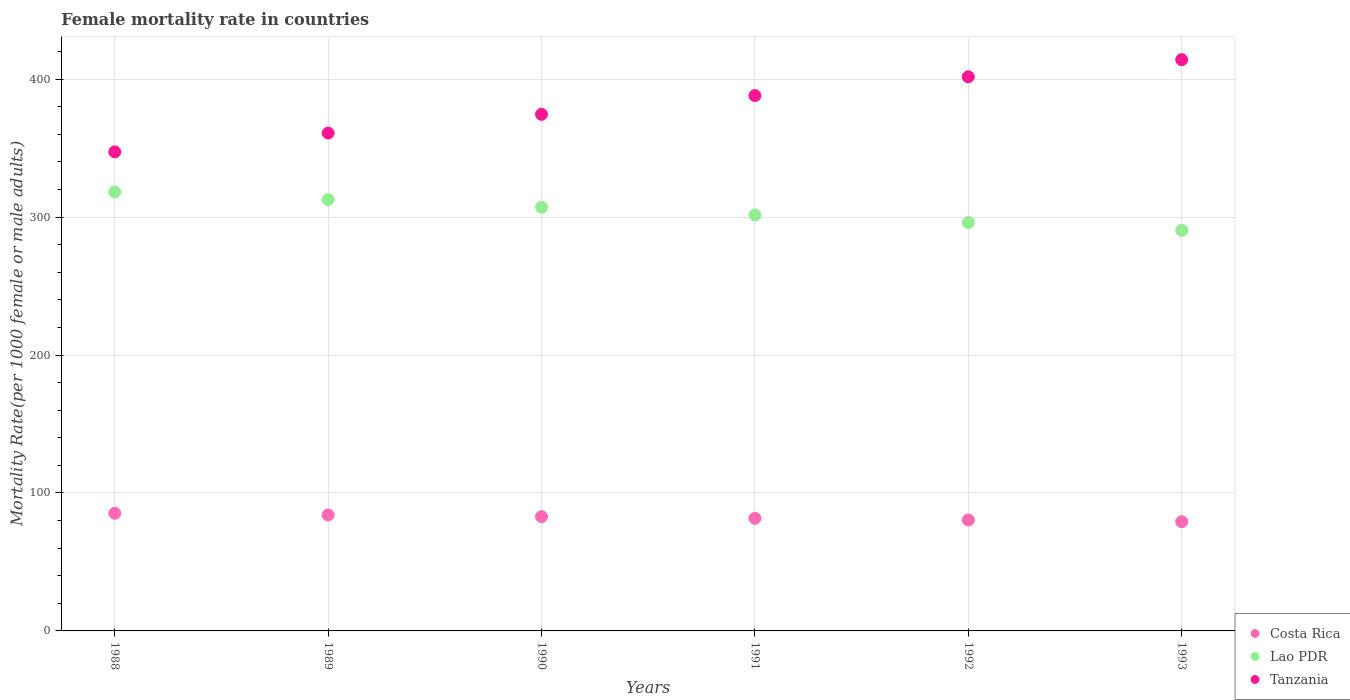What is the female mortality rate in Lao PDR in 1989?
Make the answer very short. 312.73. Across all years, what is the maximum female mortality rate in Lao PDR?
Provide a short and direct response. 318.29. Across all years, what is the minimum female mortality rate in Costa Rica?
Provide a succinct answer. 79.2. In which year was the female mortality rate in Lao PDR minimum?
Offer a terse response. 1993. What is the total female mortality rate in Lao PDR in the graph?
Provide a short and direct response. 1826.27. What is the difference between the female mortality rate in Costa Rica in 1989 and that in 1990?
Your answer should be very brief. 1.21. What is the difference between the female mortality rate in Tanzania in 1988 and the female mortality rate in Lao PDR in 1990?
Give a very brief answer. 40.15. What is the average female mortality rate in Lao PDR per year?
Your answer should be compact. 304.38. In the year 1993, what is the difference between the female mortality rate in Tanzania and female mortality rate in Costa Rica?
Your answer should be compact. 334.95. What is the ratio of the female mortality rate in Tanzania in 1990 to that in 1993?
Your response must be concise. 0.9. Is the female mortality rate in Costa Rica in 1989 less than that in 1991?
Offer a terse response. No. What is the difference between the highest and the second highest female mortality rate in Lao PDR?
Offer a terse response. 5.56. What is the difference between the highest and the lowest female mortality rate in Tanzania?
Make the answer very short. 66.83. Is the sum of the female mortality rate in Tanzania in 1989 and 1991 greater than the maximum female mortality rate in Costa Rica across all years?
Offer a terse response. Yes. How many years are there in the graph?
Your answer should be compact. 6. Are the values on the major ticks of Y-axis written in scientific E-notation?
Ensure brevity in your answer.  No. Does the graph contain any zero values?
Ensure brevity in your answer.  No. Where does the legend appear in the graph?
Offer a terse response. Bottom right. How are the legend labels stacked?
Your answer should be compact. Vertical. What is the title of the graph?
Ensure brevity in your answer.  Female mortality rate in countries. Does "Lesotho" appear as one of the legend labels in the graph?
Provide a short and direct response. No. What is the label or title of the X-axis?
Give a very brief answer. Years. What is the label or title of the Y-axis?
Keep it short and to the point. Mortality Rate(per 1000 female or male adults). What is the Mortality Rate(per 1000 female or male adults) in Costa Rica in 1988?
Offer a terse response. 85.29. What is the Mortality Rate(per 1000 female or male adults) of Lao PDR in 1988?
Give a very brief answer. 318.29. What is the Mortality Rate(per 1000 female or male adults) in Tanzania in 1988?
Make the answer very short. 347.31. What is the Mortality Rate(per 1000 female or male adults) in Costa Rica in 1989?
Provide a succinct answer. 84.08. What is the Mortality Rate(per 1000 female or male adults) in Lao PDR in 1989?
Provide a succinct answer. 312.73. What is the Mortality Rate(per 1000 female or male adults) of Tanzania in 1989?
Offer a very short reply. 360.92. What is the Mortality Rate(per 1000 female or male adults) in Costa Rica in 1990?
Give a very brief answer. 82.87. What is the Mortality Rate(per 1000 female or male adults) of Lao PDR in 1990?
Offer a terse response. 307.17. What is the Mortality Rate(per 1000 female or male adults) of Tanzania in 1990?
Keep it short and to the point. 374.53. What is the Mortality Rate(per 1000 female or male adults) of Costa Rica in 1991?
Offer a terse response. 81.65. What is the Mortality Rate(per 1000 female or male adults) in Lao PDR in 1991?
Make the answer very short. 301.6. What is the Mortality Rate(per 1000 female or male adults) of Tanzania in 1991?
Provide a short and direct response. 388.13. What is the Mortality Rate(per 1000 female or male adults) in Costa Rica in 1992?
Provide a succinct answer. 80.44. What is the Mortality Rate(per 1000 female or male adults) of Lao PDR in 1992?
Make the answer very short. 296.04. What is the Mortality Rate(per 1000 female or male adults) in Tanzania in 1992?
Your answer should be very brief. 401.74. What is the Mortality Rate(per 1000 female or male adults) in Costa Rica in 1993?
Provide a short and direct response. 79.2. What is the Mortality Rate(per 1000 female or male adults) in Lao PDR in 1993?
Your response must be concise. 290.44. What is the Mortality Rate(per 1000 female or male adults) in Tanzania in 1993?
Offer a very short reply. 414.15. Across all years, what is the maximum Mortality Rate(per 1000 female or male adults) of Costa Rica?
Offer a very short reply. 85.29. Across all years, what is the maximum Mortality Rate(per 1000 female or male adults) in Lao PDR?
Your answer should be compact. 318.29. Across all years, what is the maximum Mortality Rate(per 1000 female or male adults) of Tanzania?
Ensure brevity in your answer.  414.15. Across all years, what is the minimum Mortality Rate(per 1000 female or male adults) of Costa Rica?
Make the answer very short. 79.2. Across all years, what is the minimum Mortality Rate(per 1000 female or male adults) in Lao PDR?
Provide a short and direct response. 290.44. Across all years, what is the minimum Mortality Rate(per 1000 female or male adults) of Tanzania?
Provide a short and direct response. 347.31. What is the total Mortality Rate(per 1000 female or male adults) of Costa Rica in the graph?
Your response must be concise. 493.53. What is the total Mortality Rate(per 1000 female or male adults) of Lao PDR in the graph?
Keep it short and to the point. 1826.27. What is the total Mortality Rate(per 1000 female or male adults) in Tanzania in the graph?
Offer a very short reply. 2286.78. What is the difference between the Mortality Rate(per 1000 female or male adults) of Costa Rica in 1988 and that in 1989?
Keep it short and to the point. 1.21. What is the difference between the Mortality Rate(per 1000 female or male adults) in Lao PDR in 1988 and that in 1989?
Offer a terse response. 5.56. What is the difference between the Mortality Rate(per 1000 female or male adults) in Tanzania in 1988 and that in 1989?
Keep it short and to the point. -13.61. What is the difference between the Mortality Rate(per 1000 female or male adults) in Costa Rica in 1988 and that in 1990?
Your answer should be very brief. 2.42. What is the difference between the Mortality Rate(per 1000 female or male adults) in Lao PDR in 1988 and that in 1990?
Your answer should be compact. 11.13. What is the difference between the Mortality Rate(per 1000 female or male adults) of Tanzania in 1988 and that in 1990?
Offer a terse response. -27.21. What is the difference between the Mortality Rate(per 1000 female or male adults) of Costa Rica in 1988 and that in 1991?
Provide a succinct answer. 3.64. What is the difference between the Mortality Rate(per 1000 female or male adults) in Lao PDR in 1988 and that in 1991?
Offer a very short reply. 16.69. What is the difference between the Mortality Rate(per 1000 female or male adults) in Tanzania in 1988 and that in 1991?
Ensure brevity in your answer.  -40.82. What is the difference between the Mortality Rate(per 1000 female or male adults) of Costa Rica in 1988 and that in 1992?
Offer a very short reply. 4.85. What is the difference between the Mortality Rate(per 1000 female or male adults) of Lao PDR in 1988 and that in 1992?
Your answer should be compact. 22.25. What is the difference between the Mortality Rate(per 1000 female or male adults) of Tanzania in 1988 and that in 1992?
Give a very brief answer. -54.43. What is the difference between the Mortality Rate(per 1000 female or male adults) in Costa Rica in 1988 and that in 1993?
Keep it short and to the point. 6.09. What is the difference between the Mortality Rate(per 1000 female or male adults) of Lao PDR in 1988 and that in 1993?
Keep it short and to the point. 27.85. What is the difference between the Mortality Rate(per 1000 female or male adults) of Tanzania in 1988 and that in 1993?
Give a very brief answer. -66.83. What is the difference between the Mortality Rate(per 1000 female or male adults) of Costa Rica in 1989 and that in 1990?
Your answer should be compact. 1.21. What is the difference between the Mortality Rate(per 1000 female or male adults) in Lao PDR in 1989 and that in 1990?
Your response must be concise. 5.56. What is the difference between the Mortality Rate(per 1000 female or male adults) of Tanzania in 1989 and that in 1990?
Your answer should be compact. -13.61. What is the difference between the Mortality Rate(per 1000 female or male adults) of Costa Rica in 1989 and that in 1991?
Ensure brevity in your answer.  2.42. What is the difference between the Mortality Rate(per 1000 female or male adults) in Lao PDR in 1989 and that in 1991?
Make the answer very short. 11.13. What is the difference between the Mortality Rate(per 1000 female or male adults) in Tanzania in 1989 and that in 1991?
Your answer should be very brief. -27.21. What is the difference between the Mortality Rate(per 1000 female or male adults) of Costa Rica in 1989 and that in 1992?
Your answer should be very brief. 3.64. What is the difference between the Mortality Rate(per 1000 female or male adults) of Lao PDR in 1989 and that in 1992?
Ensure brevity in your answer.  16.69. What is the difference between the Mortality Rate(per 1000 female or male adults) of Tanzania in 1989 and that in 1992?
Provide a short and direct response. -40.82. What is the difference between the Mortality Rate(per 1000 female or male adults) of Costa Rica in 1989 and that in 1993?
Offer a very short reply. 4.88. What is the difference between the Mortality Rate(per 1000 female or male adults) in Lao PDR in 1989 and that in 1993?
Provide a short and direct response. 22.28. What is the difference between the Mortality Rate(per 1000 female or male adults) in Tanzania in 1989 and that in 1993?
Give a very brief answer. -53.23. What is the difference between the Mortality Rate(per 1000 female or male adults) in Costa Rica in 1990 and that in 1991?
Ensure brevity in your answer.  1.21. What is the difference between the Mortality Rate(per 1000 female or male adults) in Lao PDR in 1990 and that in 1991?
Your response must be concise. 5.56. What is the difference between the Mortality Rate(per 1000 female or male adults) in Tanzania in 1990 and that in 1991?
Provide a succinct answer. -13.61. What is the difference between the Mortality Rate(per 1000 female or male adults) in Costa Rica in 1990 and that in 1992?
Keep it short and to the point. 2.42. What is the difference between the Mortality Rate(per 1000 female or male adults) in Lao PDR in 1990 and that in 1992?
Provide a short and direct response. 11.13. What is the difference between the Mortality Rate(per 1000 female or male adults) of Tanzania in 1990 and that in 1992?
Give a very brief answer. -27.21. What is the difference between the Mortality Rate(per 1000 female or male adults) in Costa Rica in 1990 and that in 1993?
Ensure brevity in your answer.  3.67. What is the difference between the Mortality Rate(per 1000 female or male adults) of Lao PDR in 1990 and that in 1993?
Your response must be concise. 16.72. What is the difference between the Mortality Rate(per 1000 female or male adults) in Tanzania in 1990 and that in 1993?
Offer a very short reply. -39.62. What is the difference between the Mortality Rate(per 1000 female or male adults) in Costa Rica in 1991 and that in 1992?
Give a very brief answer. 1.21. What is the difference between the Mortality Rate(per 1000 female or male adults) of Lao PDR in 1991 and that in 1992?
Your answer should be compact. 5.56. What is the difference between the Mortality Rate(per 1000 female or male adults) of Tanzania in 1991 and that in 1992?
Keep it short and to the point. -13.61. What is the difference between the Mortality Rate(per 1000 female or male adults) of Costa Rica in 1991 and that in 1993?
Make the answer very short. 2.45. What is the difference between the Mortality Rate(per 1000 female or male adults) of Lao PDR in 1991 and that in 1993?
Provide a short and direct response. 11.16. What is the difference between the Mortality Rate(per 1000 female or male adults) of Tanzania in 1991 and that in 1993?
Ensure brevity in your answer.  -26.01. What is the difference between the Mortality Rate(per 1000 female or male adults) in Costa Rica in 1992 and that in 1993?
Make the answer very short. 1.24. What is the difference between the Mortality Rate(per 1000 female or male adults) in Lao PDR in 1992 and that in 1993?
Your answer should be very brief. 5.59. What is the difference between the Mortality Rate(per 1000 female or male adults) in Tanzania in 1992 and that in 1993?
Your response must be concise. -12.41. What is the difference between the Mortality Rate(per 1000 female or male adults) of Costa Rica in 1988 and the Mortality Rate(per 1000 female or male adults) of Lao PDR in 1989?
Your response must be concise. -227.44. What is the difference between the Mortality Rate(per 1000 female or male adults) of Costa Rica in 1988 and the Mortality Rate(per 1000 female or male adults) of Tanzania in 1989?
Give a very brief answer. -275.63. What is the difference between the Mortality Rate(per 1000 female or male adults) in Lao PDR in 1988 and the Mortality Rate(per 1000 female or male adults) in Tanzania in 1989?
Your response must be concise. -42.63. What is the difference between the Mortality Rate(per 1000 female or male adults) of Costa Rica in 1988 and the Mortality Rate(per 1000 female or male adults) of Lao PDR in 1990?
Ensure brevity in your answer.  -221.87. What is the difference between the Mortality Rate(per 1000 female or male adults) of Costa Rica in 1988 and the Mortality Rate(per 1000 female or male adults) of Tanzania in 1990?
Your response must be concise. -289.24. What is the difference between the Mortality Rate(per 1000 female or male adults) of Lao PDR in 1988 and the Mortality Rate(per 1000 female or male adults) of Tanzania in 1990?
Provide a succinct answer. -56.24. What is the difference between the Mortality Rate(per 1000 female or male adults) in Costa Rica in 1988 and the Mortality Rate(per 1000 female or male adults) in Lao PDR in 1991?
Offer a very short reply. -216.31. What is the difference between the Mortality Rate(per 1000 female or male adults) of Costa Rica in 1988 and the Mortality Rate(per 1000 female or male adults) of Tanzania in 1991?
Provide a succinct answer. -302.84. What is the difference between the Mortality Rate(per 1000 female or male adults) in Lao PDR in 1988 and the Mortality Rate(per 1000 female or male adults) in Tanzania in 1991?
Provide a succinct answer. -69.84. What is the difference between the Mortality Rate(per 1000 female or male adults) in Costa Rica in 1988 and the Mortality Rate(per 1000 female or male adults) in Lao PDR in 1992?
Keep it short and to the point. -210.75. What is the difference between the Mortality Rate(per 1000 female or male adults) of Costa Rica in 1988 and the Mortality Rate(per 1000 female or male adults) of Tanzania in 1992?
Keep it short and to the point. -316.45. What is the difference between the Mortality Rate(per 1000 female or male adults) in Lao PDR in 1988 and the Mortality Rate(per 1000 female or male adults) in Tanzania in 1992?
Your answer should be compact. -83.45. What is the difference between the Mortality Rate(per 1000 female or male adults) in Costa Rica in 1988 and the Mortality Rate(per 1000 female or male adults) in Lao PDR in 1993?
Your answer should be very brief. -205.15. What is the difference between the Mortality Rate(per 1000 female or male adults) in Costa Rica in 1988 and the Mortality Rate(per 1000 female or male adults) in Tanzania in 1993?
Keep it short and to the point. -328.86. What is the difference between the Mortality Rate(per 1000 female or male adults) in Lao PDR in 1988 and the Mortality Rate(per 1000 female or male adults) in Tanzania in 1993?
Offer a terse response. -95.86. What is the difference between the Mortality Rate(per 1000 female or male adults) of Costa Rica in 1989 and the Mortality Rate(per 1000 female or male adults) of Lao PDR in 1990?
Ensure brevity in your answer.  -223.09. What is the difference between the Mortality Rate(per 1000 female or male adults) in Costa Rica in 1989 and the Mortality Rate(per 1000 female or male adults) in Tanzania in 1990?
Your response must be concise. -290.45. What is the difference between the Mortality Rate(per 1000 female or male adults) of Lao PDR in 1989 and the Mortality Rate(per 1000 female or male adults) of Tanzania in 1990?
Offer a very short reply. -61.8. What is the difference between the Mortality Rate(per 1000 female or male adults) of Costa Rica in 1989 and the Mortality Rate(per 1000 female or male adults) of Lao PDR in 1991?
Your answer should be compact. -217.52. What is the difference between the Mortality Rate(per 1000 female or male adults) in Costa Rica in 1989 and the Mortality Rate(per 1000 female or male adults) in Tanzania in 1991?
Offer a very short reply. -304.06. What is the difference between the Mortality Rate(per 1000 female or male adults) in Lao PDR in 1989 and the Mortality Rate(per 1000 female or male adults) in Tanzania in 1991?
Your answer should be compact. -75.41. What is the difference between the Mortality Rate(per 1000 female or male adults) of Costa Rica in 1989 and the Mortality Rate(per 1000 female or male adults) of Lao PDR in 1992?
Provide a succinct answer. -211.96. What is the difference between the Mortality Rate(per 1000 female or male adults) in Costa Rica in 1989 and the Mortality Rate(per 1000 female or male adults) in Tanzania in 1992?
Give a very brief answer. -317.66. What is the difference between the Mortality Rate(per 1000 female or male adults) of Lao PDR in 1989 and the Mortality Rate(per 1000 female or male adults) of Tanzania in 1992?
Provide a short and direct response. -89.01. What is the difference between the Mortality Rate(per 1000 female or male adults) of Costa Rica in 1989 and the Mortality Rate(per 1000 female or male adults) of Lao PDR in 1993?
Your answer should be very brief. -206.37. What is the difference between the Mortality Rate(per 1000 female or male adults) of Costa Rica in 1989 and the Mortality Rate(per 1000 female or male adults) of Tanzania in 1993?
Provide a short and direct response. -330.07. What is the difference between the Mortality Rate(per 1000 female or male adults) of Lao PDR in 1989 and the Mortality Rate(per 1000 female or male adults) of Tanzania in 1993?
Your response must be concise. -101.42. What is the difference between the Mortality Rate(per 1000 female or male adults) in Costa Rica in 1990 and the Mortality Rate(per 1000 female or male adults) in Lao PDR in 1991?
Offer a very short reply. -218.74. What is the difference between the Mortality Rate(per 1000 female or male adults) in Costa Rica in 1990 and the Mortality Rate(per 1000 female or male adults) in Tanzania in 1991?
Provide a succinct answer. -305.27. What is the difference between the Mortality Rate(per 1000 female or male adults) of Lao PDR in 1990 and the Mortality Rate(per 1000 female or male adults) of Tanzania in 1991?
Offer a terse response. -80.97. What is the difference between the Mortality Rate(per 1000 female or male adults) of Costa Rica in 1990 and the Mortality Rate(per 1000 female or male adults) of Lao PDR in 1992?
Your answer should be compact. -213.17. What is the difference between the Mortality Rate(per 1000 female or male adults) of Costa Rica in 1990 and the Mortality Rate(per 1000 female or male adults) of Tanzania in 1992?
Offer a very short reply. -318.87. What is the difference between the Mortality Rate(per 1000 female or male adults) in Lao PDR in 1990 and the Mortality Rate(per 1000 female or male adults) in Tanzania in 1992?
Give a very brief answer. -94.58. What is the difference between the Mortality Rate(per 1000 female or male adults) in Costa Rica in 1990 and the Mortality Rate(per 1000 female or male adults) in Lao PDR in 1993?
Offer a very short reply. -207.58. What is the difference between the Mortality Rate(per 1000 female or male adults) in Costa Rica in 1990 and the Mortality Rate(per 1000 female or male adults) in Tanzania in 1993?
Your answer should be compact. -331.28. What is the difference between the Mortality Rate(per 1000 female or male adults) of Lao PDR in 1990 and the Mortality Rate(per 1000 female or male adults) of Tanzania in 1993?
Make the answer very short. -106.98. What is the difference between the Mortality Rate(per 1000 female or male adults) of Costa Rica in 1991 and the Mortality Rate(per 1000 female or male adults) of Lao PDR in 1992?
Provide a succinct answer. -214.39. What is the difference between the Mortality Rate(per 1000 female or male adults) of Costa Rica in 1991 and the Mortality Rate(per 1000 female or male adults) of Tanzania in 1992?
Your answer should be very brief. -320.09. What is the difference between the Mortality Rate(per 1000 female or male adults) in Lao PDR in 1991 and the Mortality Rate(per 1000 female or male adults) in Tanzania in 1992?
Your answer should be very brief. -100.14. What is the difference between the Mortality Rate(per 1000 female or male adults) in Costa Rica in 1991 and the Mortality Rate(per 1000 female or male adults) in Lao PDR in 1993?
Ensure brevity in your answer.  -208.79. What is the difference between the Mortality Rate(per 1000 female or male adults) in Costa Rica in 1991 and the Mortality Rate(per 1000 female or male adults) in Tanzania in 1993?
Offer a very short reply. -332.49. What is the difference between the Mortality Rate(per 1000 female or male adults) in Lao PDR in 1991 and the Mortality Rate(per 1000 female or male adults) in Tanzania in 1993?
Keep it short and to the point. -112.55. What is the difference between the Mortality Rate(per 1000 female or male adults) of Costa Rica in 1992 and the Mortality Rate(per 1000 female or male adults) of Lao PDR in 1993?
Provide a succinct answer. -210. What is the difference between the Mortality Rate(per 1000 female or male adults) in Costa Rica in 1992 and the Mortality Rate(per 1000 female or male adults) in Tanzania in 1993?
Keep it short and to the point. -333.71. What is the difference between the Mortality Rate(per 1000 female or male adults) in Lao PDR in 1992 and the Mortality Rate(per 1000 female or male adults) in Tanzania in 1993?
Your answer should be very brief. -118.11. What is the average Mortality Rate(per 1000 female or male adults) of Costa Rica per year?
Your answer should be compact. 82.25. What is the average Mortality Rate(per 1000 female or male adults) of Lao PDR per year?
Provide a short and direct response. 304.38. What is the average Mortality Rate(per 1000 female or male adults) of Tanzania per year?
Provide a short and direct response. 381.13. In the year 1988, what is the difference between the Mortality Rate(per 1000 female or male adults) of Costa Rica and Mortality Rate(per 1000 female or male adults) of Lao PDR?
Provide a short and direct response. -233. In the year 1988, what is the difference between the Mortality Rate(per 1000 female or male adults) of Costa Rica and Mortality Rate(per 1000 female or male adults) of Tanzania?
Ensure brevity in your answer.  -262.02. In the year 1988, what is the difference between the Mortality Rate(per 1000 female or male adults) in Lao PDR and Mortality Rate(per 1000 female or male adults) in Tanzania?
Give a very brief answer. -29.02. In the year 1989, what is the difference between the Mortality Rate(per 1000 female or male adults) of Costa Rica and Mortality Rate(per 1000 female or male adults) of Lao PDR?
Ensure brevity in your answer.  -228.65. In the year 1989, what is the difference between the Mortality Rate(per 1000 female or male adults) in Costa Rica and Mortality Rate(per 1000 female or male adults) in Tanzania?
Your answer should be very brief. -276.84. In the year 1989, what is the difference between the Mortality Rate(per 1000 female or male adults) in Lao PDR and Mortality Rate(per 1000 female or male adults) in Tanzania?
Your response must be concise. -48.19. In the year 1990, what is the difference between the Mortality Rate(per 1000 female or male adults) in Costa Rica and Mortality Rate(per 1000 female or male adults) in Lao PDR?
Keep it short and to the point. -224.3. In the year 1990, what is the difference between the Mortality Rate(per 1000 female or male adults) of Costa Rica and Mortality Rate(per 1000 female or male adults) of Tanzania?
Give a very brief answer. -291.66. In the year 1990, what is the difference between the Mortality Rate(per 1000 female or male adults) in Lao PDR and Mortality Rate(per 1000 female or male adults) in Tanzania?
Make the answer very short. -67.36. In the year 1991, what is the difference between the Mortality Rate(per 1000 female or male adults) of Costa Rica and Mortality Rate(per 1000 female or male adults) of Lao PDR?
Offer a very short reply. -219.95. In the year 1991, what is the difference between the Mortality Rate(per 1000 female or male adults) in Costa Rica and Mortality Rate(per 1000 female or male adults) in Tanzania?
Your response must be concise. -306.48. In the year 1991, what is the difference between the Mortality Rate(per 1000 female or male adults) in Lao PDR and Mortality Rate(per 1000 female or male adults) in Tanzania?
Make the answer very short. -86.53. In the year 1992, what is the difference between the Mortality Rate(per 1000 female or male adults) of Costa Rica and Mortality Rate(per 1000 female or male adults) of Lao PDR?
Your response must be concise. -215.6. In the year 1992, what is the difference between the Mortality Rate(per 1000 female or male adults) of Costa Rica and Mortality Rate(per 1000 female or male adults) of Tanzania?
Ensure brevity in your answer.  -321.3. In the year 1992, what is the difference between the Mortality Rate(per 1000 female or male adults) in Lao PDR and Mortality Rate(per 1000 female or male adults) in Tanzania?
Provide a short and direct response. -105.7. In the year 1993, what is the difference between the Mortality Rate(per 1000 female or male adults) of Costa Rica and Mortality Rate(per 1000 female or male adults) of Lao PDR?
Provide a short and direct response. -211.24. In the year 1993, what is the difference between the Mortality Rate(per 1000 female or male adults) in Costa Rica and Mortality Rate(per 1000 female or male adults) in Tanzania?
Your response must be concise. -334.95. In the year 1993, what is the difference between the Mortality Rate(per 1000 female or male adults) of Lao PDR and Mortality Rate(per 1000 female or male adults) of Tanzania?
Make the answer very short. -123.7. What is the ratio of the Mortality Rate(per 1000 female or male adults) of Costa Rica in 1988 to that in 1989?
Make the answer very short. 1.01. What is the ratio of the Mortality Rate(per 1000 female or male adults) in Lao PDR in 1988 to that in 1989?
Offer a terse response. 1.02. What is the ratio of the Mortality Rate(per 1000 female or male adults) in Tanzania in 1988 to that in 1989?
Offer a terse response. 0.96. What is the ratio of the Mortality Rate(per 1000 female or male adults) in Costa Rica in 1988 to that in 1990?
Offer a terse response. 1.03. What is the ratio of the Mortality Rate(per 1000 female or male adults) of Lao PDR in 1988 to that in 1990?
Offer a terse response. 1.04. What is the ratio of the Mortality Rate(per 1000 female or male adults) of Tanzania in 1988 to that in 1990?
Provide a short and direct response. 0.93. What is the ratio of the Mortality Rate(per 1000 female or male adults) in Costa Rica in 1988 to that in 1991?
Your answer should be compact. 1.04. What is the ratio of the Mortality Rate(per 1000 female or male adults) of Lao PDR in 1988 to that in 1991?
Make the answer very short. 1.06. What is the ratio of the Mortality Rate(per 1000 female or male adults) in Tanzania in 1988 to that in 1991?
Your answer should be very brief. 0.89. What is the ratio of the Mortality Rate(per 1000 female or male adults) in Costa Rica in 1988 to that in 1992?
Make the answer very short. 1.06. What is the ratio of the Mortality Rate(per 1000 female or male adults) of Lao PDR in 1988 to that in 1992?
Offer a terse response. 1.08. What is the ratio of the Mortality Rate(per 1000 female or male adults) in Tanzania in 1988 to that in 1992?
Keep it short and to the point. 0.86. What is the ratio of the Mortality Rate(per 1000 female or male adults) in Costa Rica in 1988 to that in 1993?
Give a very brief answer. 1.08. What is the ratio of the Mortality Rate(per 1000 female or male adults) of Lao PDR in 1988 to that in 1993?
Make the answer very short. 1.1. What is the ratio of the Mortality Rate(per 1000 female or male adults) of Tanzania in 1988 to that in 1993?
Offer a very short reply. 0.84. What is the ratio of the Mortality Rate(per 1000 female or male adults) of Costa Rica in 1989 to that in 1990?
Your answer should be very brief. 1.01. What is the ratio of the Mortality Rate(per 1000 female or male adults) of Lao PDR in 1989 to that in 1990?
Offer a terse response. 1.02. What is the ratio of the Mortality Rate(per 1000 female or male adults) in Tanzania in 1989 to that in 1990?
Offer a terse response. 0.96. What is the ratio of the Mortality Rate(per 1000 female or male adults) of Costa Rica in 1989 to that in 1991?
Offer a terse response. 1.03. What is the ratio of the Mortality Rate(per 1000 female or male adults) in Lao PDR in 1989 to that in 1991?
Ensure brevity in your answer.  1.04. What is the ratio of the Mortality Rate(per 1000 female or male adults) of Tanzania in 1989 to that in 1991?
Provide a short and direct response. 0.93. What is the ratio of the Mortality Rate(per 1000 female or male adults) of Costa Rica in 1989 to that in 1992?
Offer a terse response. 1.05. What is the ratio of the Mortality Rate(per 1000 female or male adults) of Lao PDR in 1989 to that in 1992?
Your response must be concise. 1.06. What is the ratio of the Mortality Rate(per 1000 female or male adults) of Tanzania in 1989 to that in 1992?
Keep it short and to the point. 0.9. What is the ratio of the Mortality Rate(per 1000 female or male adults) in Costa Rica in 1989 to that in 1993?
Provide a short and direct response. 1.06. What is the ratio of the Mortality Rate(per 1000 female or male adults) in Lao PDR in 1989 to that in 1993?
Ensure brevity in your answer.  1.08. What is the ratio of the Mortality Rate(per 1000 female or male adults) of Tanzania in 1989 to that in 1993?
Provide a succinct answer. 0.87. What is the ratio of the Mortality Rate(per 1000 female or male adults) of Costa Rica in 1990 to that in 1991?
Give a very brief answer. 1.01. What is the ratio of the Mortality Rate(per 1000 female or male adults) in Lao PDR in 1990 to that in 1991?
Offer a very short reply. 1.02. What is the ratio of the Mortality Rate(per 1000 female or male adults) of Tanzania in 1990 to that in 1991?
Keep it short and to the point. 0.96. What is the ratio of the Mortality Rate(per 1000 female or male adults) in Costa Rica in 1990 to that in 1992?
Offer a terse response. 1.03. What is the ratio of the Mortality Rate(per 1000 female or male adults) in Lao PDR in 1990 to that in 1992?
Give a very brief answer. 1.04. What is the ratio of the Mortality Rate(per 1000 female or male adults) in Tanzania in 1990 to that in 1992?
Keep it short and to the point. 0.93. What is the ratio of the Mortality Rate(per 1000 female or male adults) of Costa Rica in 1990 to that in 1993?
Offer a very short reply. 1.05. What is the ratio of the Mortality Rate(per 1000 female or male adults) in Lao PDR in 1990 to that in 1993?
Keep it short and to the point. 1.06. What is the ratio of the Mortality Rate(per 1000 female or male adults) of Tanzania in 1990 to that in 1993?
Give a very brief answer. 0.9. What is the ratio of the Mortality Rate(per 1000 female or male adults) in Costa Rica in 1991 to that in 1992?
Offer a terse response. 1.02. What is the ratio of the Mortality Rate(per 1000 female or male adults) of Lao PDR in 1991 to that in 1992?
Your answer should be compact. 1.02. What is the ratio of the Mortality Rate(per 1000 female or male adults) in Tanzania in 1991 to that in 1992?
Give a very brief answer. 0.97. What is the ratio of the Mortality Rate(per 1000 female or male adults) of Costa Rica in 1991 to that in 1993?
Provide a succinct answer. 1.03. What is the ratio of the Mortality Rate(per 1000 female or male adults) in Lao PDR in 1991 to that in 1993?
Your answer should be very brief. 1.04. What is the ratio of the Mortality Rate(per 1000 female or male adults) in Tanzania in 1991 to that in 1993?
Make the answer very short. 0.94. What is the ratio of the Mortality Rate(per 1000 female or male adults) of Costa Rica in 1992 to that in 1993?
Offer a very short reply. 1.02. What is the ratio of the Mortality Rate(per 1000 female or male adults) of Lao PDR in 1992 to that in 1993?
Make the answer very short. 1.02. What is the ratio of the Mortality Rate(per 1000 female or male adults) in Tanzania in 1992 to that in 1993?
Provide a short and direct response. 0.97. What is the difference between the highest and the second highest Mortality Rate(per 1000 female or male adults) of Costa Rica?
Your answer should be compact. 1.21. What is the difference between the highest and the second highest Mortality Rate(per 1000 female or male adults) of Lao PDR?
Provide a short and direct response. 5.56. What is the difference between the highest and the second highest Mortality Rate(per 1000 female or male adults) of Tanzania?
Offer a terse response. 12.41. What is the difference between the highest and the lowest Mortality Rate(per 1000 female or male adults) of Costa Rica?
Give a very brief answer. 6.09. What is the difference between the highest and the lowest Mortality Rate(per 1000 female or male adults) in Lao PDR?
Keep it short and to the point. 27.85. What is the difference between the highest and the lowest Mortality Rate(per 1000 female or male adults) in Tanzania?
Provide a short and direct response. 66.83. 